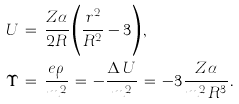<formula> <loc_0><loc_0><loc_500><loc_500>& U \, = \, \frac { Z \alpha } { 2 R } \left ( \frac { r ^ { 2 } } { R ^ { 2 } } - 3 \right ) , \\ & \Upsilon \, = \, \frac { e \rho } { m ^ { 2 } } \, = \, - \frac { \Delta \, U } { m ^ { 2 } } \, = \, - 3 \frac { Z \alpha } { m ^ { 2 } \, R ^ { 3 } } .</formula> 